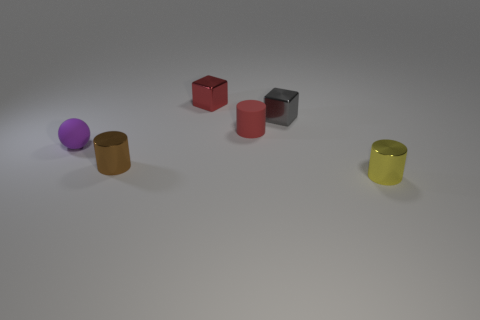Add 3 large gray spheres. How many objects exist? 9 Subtract all cubes. How many objects are left? 4 Add 1 small red metal blocks. How many small red metal blocks are left? 2 Add 6 tiny metal cylinders. How many tiny metal cylinders exist? 8 Subtract 1 yellow cylinders. How many objects are left? 5 Subtract all tiny matte cylinders. Subtract all tiny shiny cubes. How many objects are left? 3 